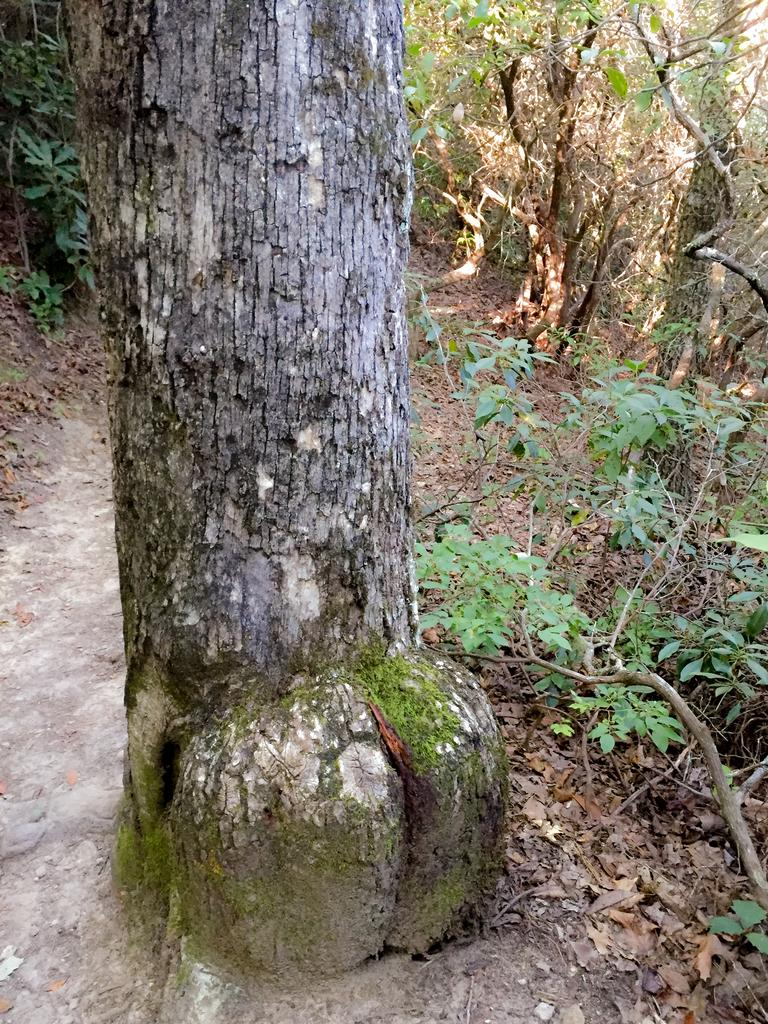What type of tree can be seen in the image? There is a truncated tree in the image. What other types of vegetation are present in the image? There are plants in the image. What can be found on the ground in the image? Leaves are present on the ground in the image. What type of horse is being judged by the panel in the image? There is no horse or panel of judges present in the image; it features a truncated tree and plants. What type of pleasure can be derived from the image? The image does not depict a pleasurable activity or scene, so it is not possible to determine what type of pleasure might be derived from it. 